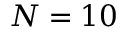<formula> <loc_0><loc_0><loc_500><loc_500>N = 1 0</formula> 